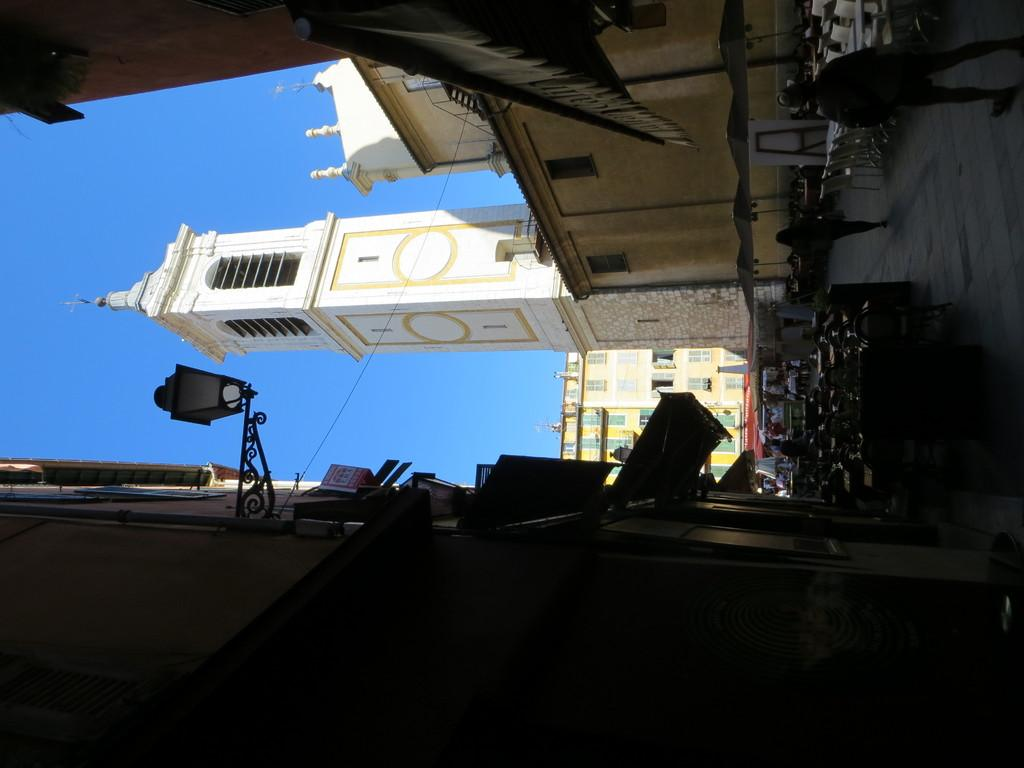What type of structures are present in the image? There are buildings in the image. What type of furniture is visible in the image? There are tables and chairs in the image. Can you describe the people in the image? There is a group of people in the image. Where is the light source located in the image? There is a light on the left side of the image. What is the eye color of the person in the image? There is no specific person mentioned in the image, and therefore no eye color can be determined. What is the argument about in the image? There is no argument present in the image; it features buildings, tables, chairs, a group of people, and a light. 